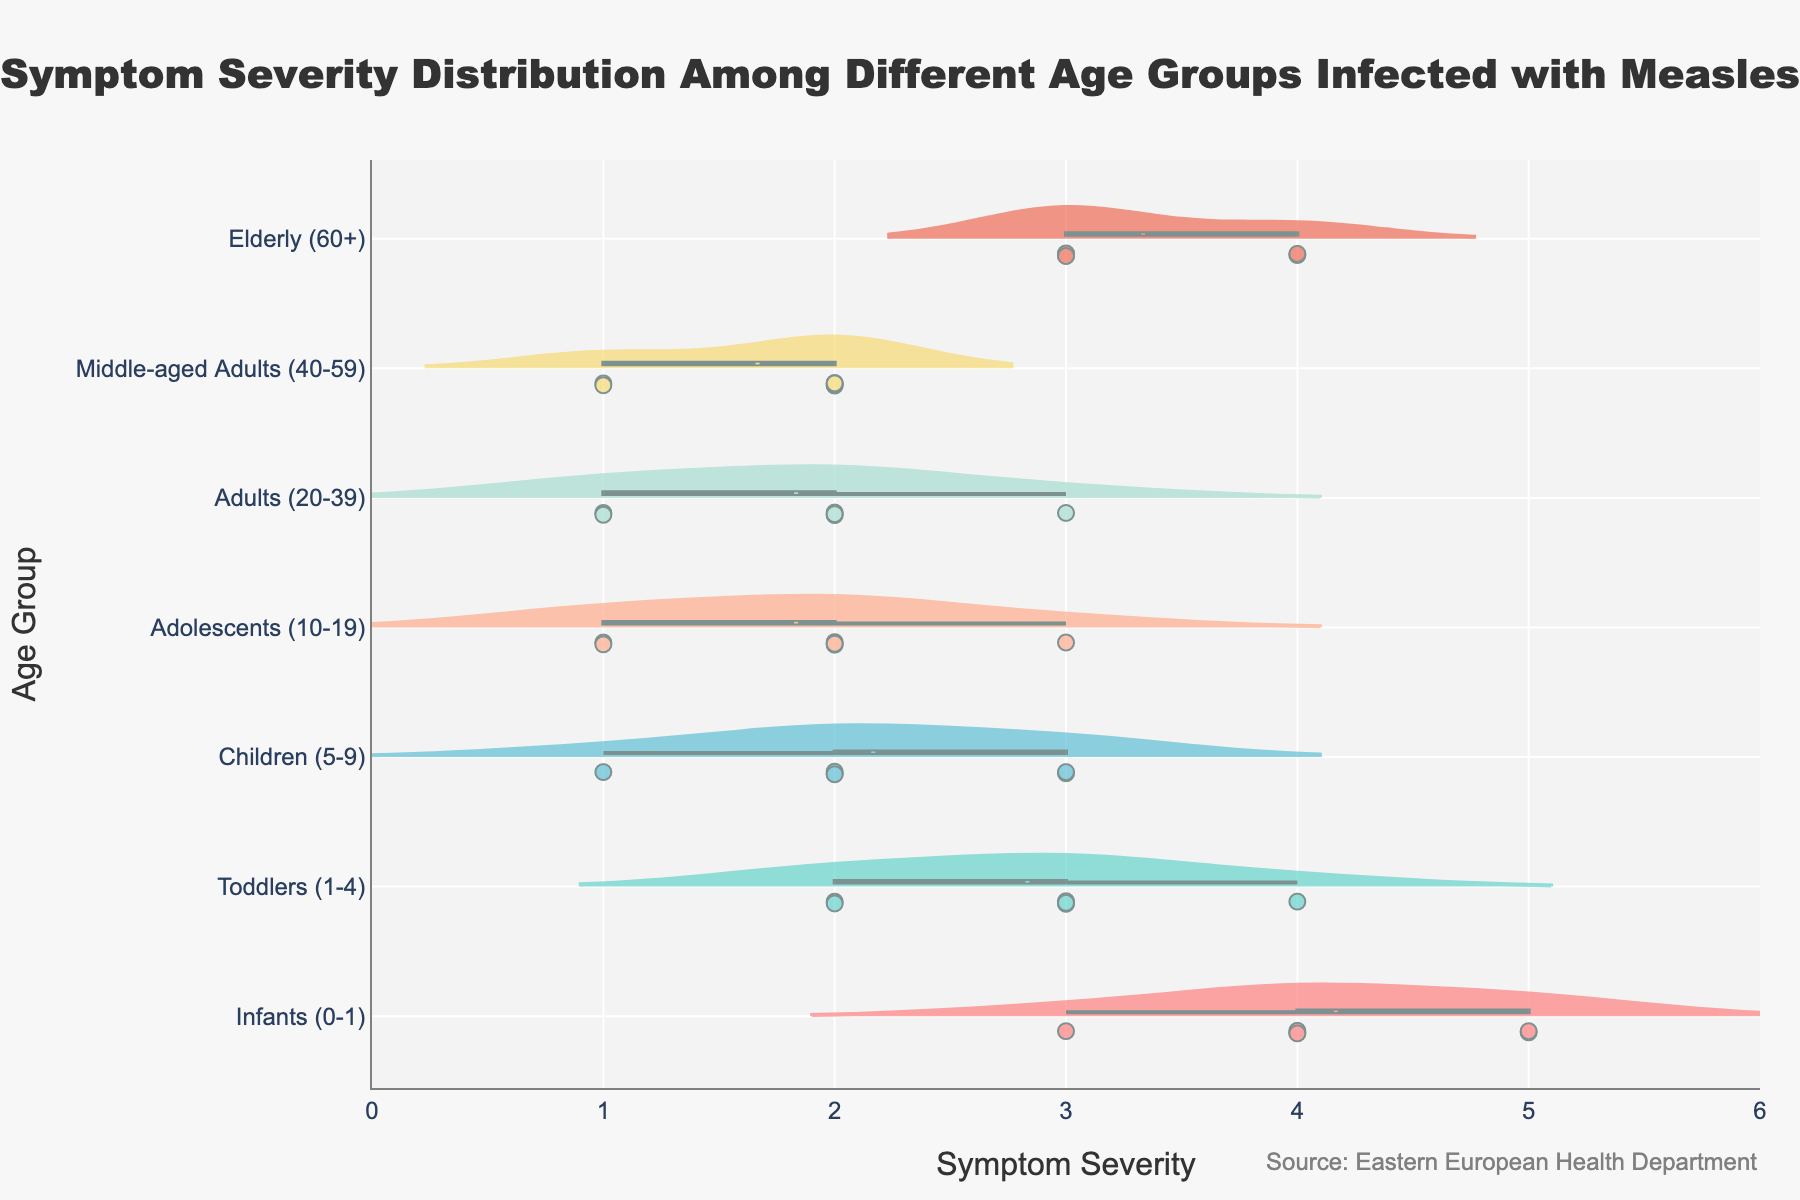What is the title of the graph? The title of the graph is usually located at the top. In this case, it states, "Symptom Severity Distribution Among Different Age Groups Infected with Measles."
Answer: Symptom Severity Distribution Among Different Age Groups Infected with Measles Which age group shows the highest median symptom severity? The median is represented by the horizontal line within the violin plot. Looking at the plots, Infants (0-1) show the highest median severity.
Answer: Infants (0-1) Which age group has the widest range of symptom severity? The range can be identified by the span of the violin plot from the lowest to highest points. Infants (0-1) show the widest range, covering from about 3 to 5.
Answer: Infants (0-1) What is the average symptom severity for Toddlers (1-4)? The data points for Toddlers (1-4) are 2, 2, 3, 4, 2, 3. Summing these values gives 16, and there are 6 points, so the average is 16/6.
Answer: 2.67 Between which age groups is the symptom severity distribution most similar? The similarity in distribution can be assessed visually by comparing the shapes and ranges of the violin plots. Adolescents (10-19) and Adults (20-39) have similar shapes and ranges.
Answer: Adolescents (10-19) and Adults (20-39) Which age group has the smallest variation in symptom severity? The variation is observed by the width and spread of the violin plot. Middle-aged Adults (40-59) have the least spread, showing consistency in symptoms severity around 1 to 2.
Answer: Middle-aged Adults (40-59) Are any age groups showing bimodal distributions? Bimodal distributions would show two peaks within the violin plot. Reviewing the plots, no age groups visually appear to show bimodal distributions.
Answer: No How many points are plotted within the Infants (0-1) age group? The individual points are visible as dots within the violin plot. By counting them, we see there are 6 points for the Infants (0-1) group.
Answer: 6 Which age group has the highest maximum point of symptom severity? The highest points on the X-axis within the violin plots indicate the maximum severity. The Elderly (60+) group shows the highest maximum symptom severity at 4.
Answer: Elderly (60+) 